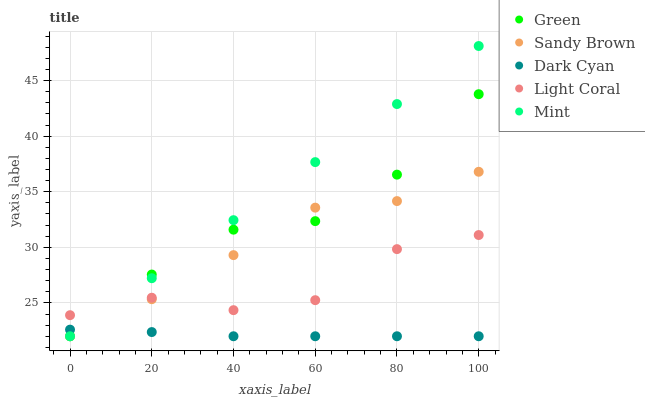Does Dark Cyan have the minimum area under the curve?
Answer yes or no. Yes. Does Mint have the maximum area under the curve?
Answer yes or no. Yes. Does Sandy Brown have the minimum area under the curve?
Answer yes or no. No. Does Sandy Brown have the maximum area under the curve?
Answer yes or no. No. Is Mint the smoothest?
Answer yes or no. Yes. Is Light Coral the roughest?
Answer yes or no. Yes. Is Sandy Brown the smoothest?
Answer yes or no. No. Is Sandy Brown the roughest?
Answer yes or no. No. Does Dark Cyan have the lowest value?
Answer yes or no. Yes. Does Light Coral have the lowest value?
Answer yes or no. No. Does Mint have the highest value?
Answer yes or no. Yes. Does Sandy Brown have the highest value?
Answer yes or no. No. Is Dark Cyan less than Light Coral?
Answer yes or no. Yes. Is Light Coral greater than Dark Cyan?
Answer yes or no. Yes. Does Sandy Brown intersect Light Coral?
Answer yes or no. Yes. Is Sandy Brown less than Light Coral?
Answer yes or no. No. Is Sandy Brown greater than Light Coral?
Answer yes or no. No. Does Dark Cyan intersect Light Coral?
Answer yes or no. No. 